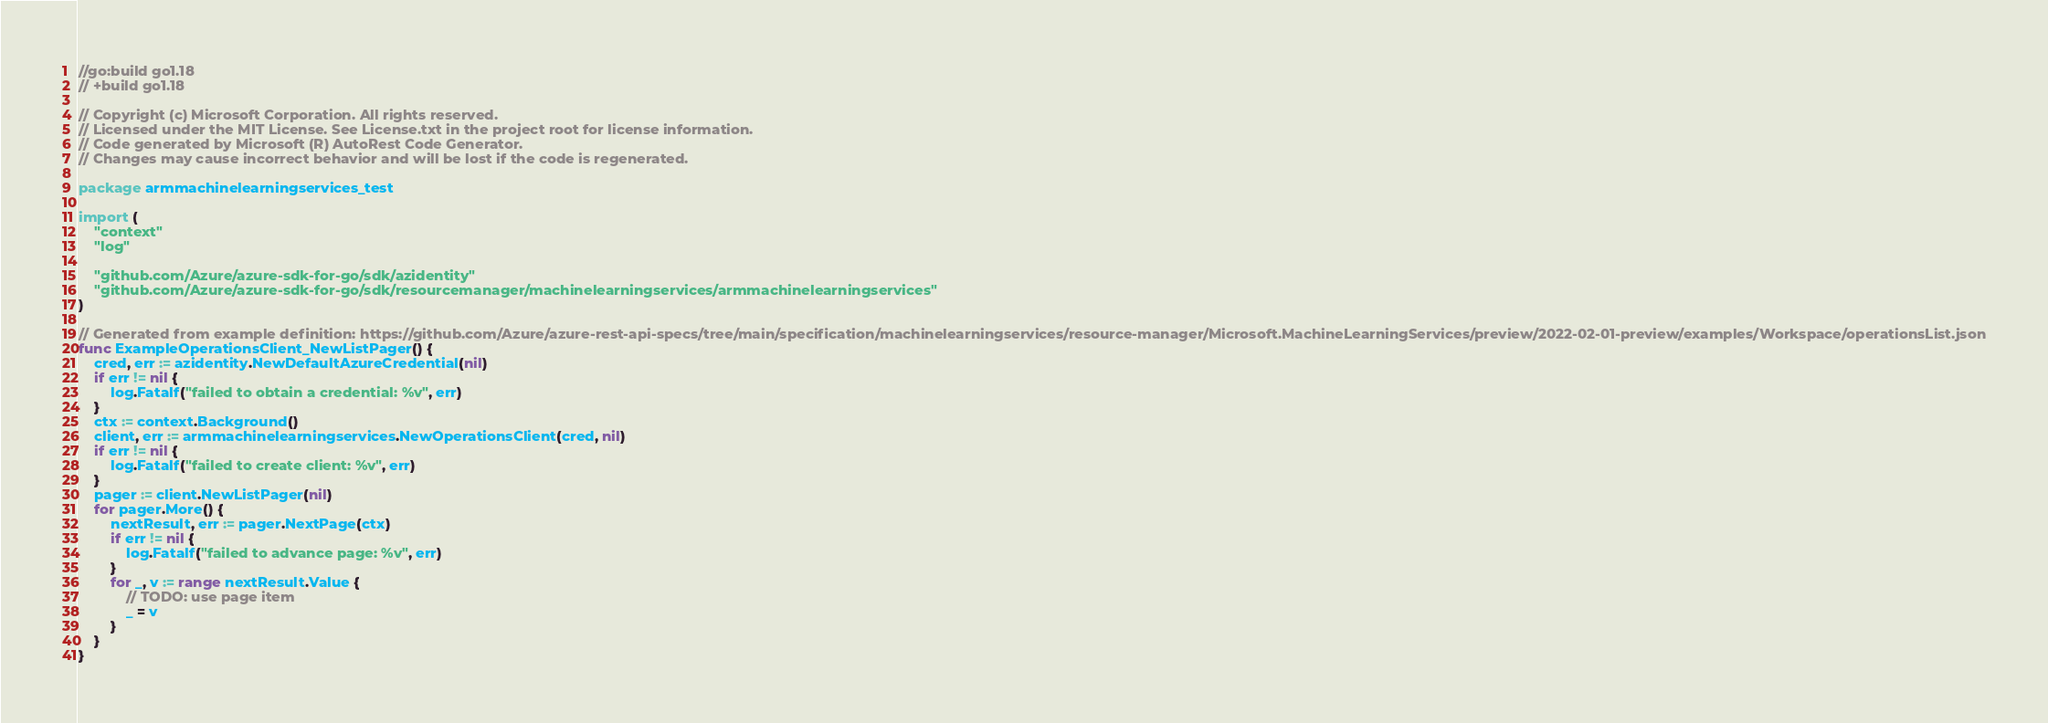Convert code to text. <code><loc_0><loc_0><loc_500><loc_500><_Go_>//go:build go1.18
// +build go1.18

// Copyright (c) Microsoft Corporation. All rights reserved.
// Licensed under the MIT License. See License.txt in the project root for license information.
// Code generated by Microsoft (R) AutoRest Code Generator.
// Changes may cause incorrect behavior and will be lost if the code is regenerated.

package armmachinelearningservices_test

import (
	"context"
	"log"

	"github.com/Azure/azure-sdk-for-go/sdk/azidentity"
	"github.com/Azure/azure-sdk-for-go/sdk/resourcemanager/machinelearningservices/armmachinelearningservices"
)

// Generated from example definition: https://github.com/Azure/azure-rest-api-specs/tree/main/specification/machinelearningservices/resource-manager/Microsoft.MachineLearningServices/preview/2022-02-01-preview/examples/Workspace/operationsList.json
func ExampleOperationsClient_NewListPager() {
	cred, err := azidentity.NewDefaultAzureCredential(nil)
	if err != nil {
		log.Fatalf("failed to obtain a credential: %v", err)
	}
	ctx := context.Background()
	client, err := armmachinelearningservices.NewOperationsClient(cred, nil)
	if err != nil {
		log.Fatalf("failed to create client: %v", err)
	}
	pager := client.NewListPager(nil)
	for pager.More() {
		nextResult, err := pager.NextPage(ctx)
		if err != nil {
			log.Fatalf("failed to advance page: %v", err)
		}
		for _, v := range nextResult.Value {
			// TODO: use page item
			_ = v
		}
	}
}
</code> 